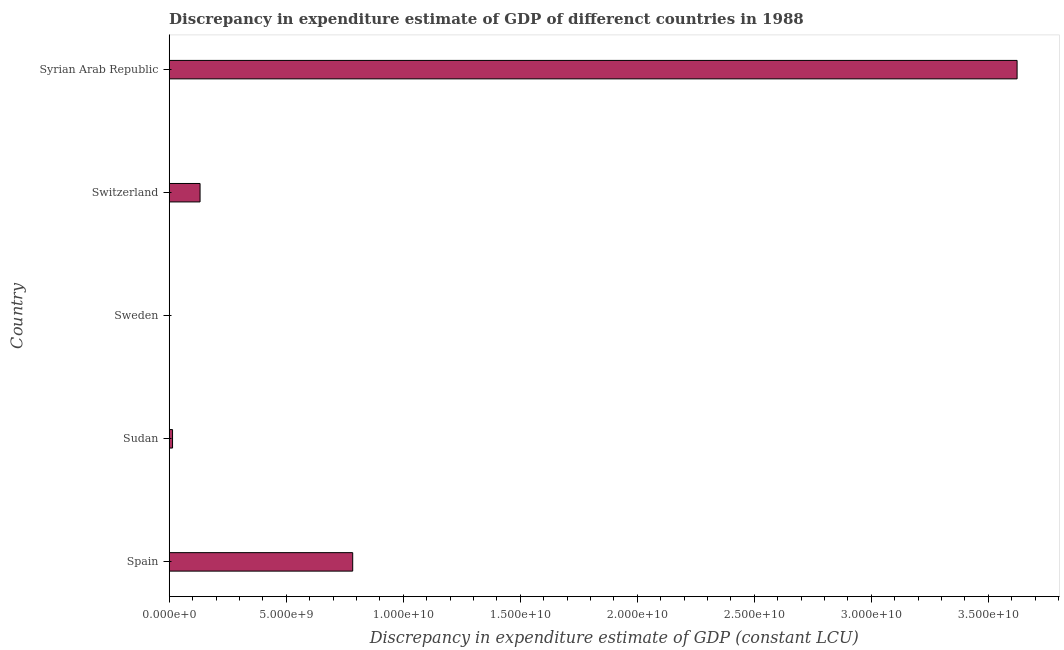Does the graph contain any zero values?
Offer a terse response. Yes. Does the graph contain grids?
Keep it short and to the point. No. What is the title of the graph?
Provide a succinct answer. Discrepancy in expenditure estimate of GDP of differenct countries in 1988. What is the label or title of the X-axis?
Keep it short and to the point. Discrepancy in expenditure estimate of GDP (constant LCU). What is the discrepancy in expenditure estimate of gdp in Switzerland?
Give a very brief answer. 1.32e+09. Across all countries, what is the maximum discrepancy in expenditure estimate of gdp?
Offer a very short reply. 3.62e+1. Across all countries, what is the minimum discrepancy in expenditure estimate of gdp?
Provide a short and direct response. 0. In which country was the discrepancy in expenditure estimate of gdp maximum?
Provide a succinct answer. Syrian Arab Republic. What is the sum of the discrepancy in expenditure estimate of gdp?
Make the answer very short. 4.55e+1. What is the difference between the discrepancy in expenditure estimate of gdp in Spain and Sudan?
Keep it short and to the point. 7.70e+09. What is the average discrepancy in expenditure estimate of gdp per country?
Provide a short and direct response. 9.11e+09. What is the median discrepancy in expenditure estimate of gdp?
Make the answer very short. 1.32e+09. What is the ratio of the discrepancy in expenditure estimate of gdp in Spain to that in Switzerland?
Ensure brevity in your answer.  5.95. Is the discrepancy in expenditure estimate of gdp in Spain less than that in Sudan?
Offer a terse response. No. Is the difference between the discrepancy in expenditure estimate of gdp in Sudan and Switzerland greater than the difference between any two countries?
Offer a very short reply. No. What is the difference between the highest and the second highest discrepancy in expenditure estimate of gdp?
Your answer should be compact. 2.84e+1. Is the sum of the discrepancy in expenditure estimate of gdp in Spain and Switzerland greater than the maximum discrepancy in expenditure estimate of gdp across all countries?
Your answer should be compact. No. What is the difference between the highest and the lowest discrepancy in expenditure estimate of gdp?
Provide a short and direct response. 3.62e+1. In how many countries, is the discrepancy in expenditure estimate of gdp greater than the average discrepancy in expenditure estimate of gdp taken over all countries?
Offer a very short reply. 1. How many countries are there in the graph?
Provide a succinct answer. 5. What is the Discrepancy in expenditure estimate of GDP (constant LCU) in Spain?
Provide a succinct answer. 7.84e+09. What is the Discrepancy in expenditure estimate of GDP (constant LCU) of Sudan?
Give a very brief answer. 1.43e+08. What is the Discrepancy in expenditure estimate of GDP (constant LCU) of Switzerland?
Provide a short and direct response. 1.32e+09. What is the Discrepancy in expenditure estimate of GDP (constant LCU) of Syrian Arab Republic?
Offer a terse response. 3.62e+1. What is the difference between the Discrepancy in expenditure estimate of GDP (constant LCU) in Spain and Sudan?
Keep it short and to the point. 7.70e+09. What is the difference between the Discrepancy in expenditure estimate of GDP (constant LCU) in Spain and Switzerland?
Keep it short and to the point. 6.52e+09. What is the difference between the Discrepancy in expenditure estimate of GDP (constant LCU) in Spain and Syrian Arab Republic?
Your answer should be very brief. -2.84e+1. What is the difference between the Discrepancy in expenditure estimate of GDP (constant LCU) in Sudan and Switzerland?
Offer a terse response. -1.18e+09. What is the difference between the Discrepancy in expenditure estimate of GDP (constant LCU) in Sudan and Syrian Arab Republic?
Ensure brevity in your answer.  -3.61e+1. What is the difference between the Discrepancy in expenditure estimate of GDP (constant LCU) in Switzerland and Syrian Arab Republic?
Provide a succinct answer. -3.49e+1. What is the ratio of the Discrepancy in expenditure estimate of GDP (constant LCU) in Spain to that in Sudan?
Provide a short and direct response. 54.9. What is the ratio of the Discrepancy in expenditure estimate of GDP (constant LCU) in Spain to that in Switzerland?
Your answer should be very brief. 5.95. What is the ratio of the Discrepancy in expenditure estimate of GDP (constant LCU) in Spain to that in Syrian Arab Republic?
Keep it short and to the point. 0.22. What is the ratio of the Discrepancy in expenditure estimate of GDP (constant LCU) in Sudan to that in Switzerland?
Your answer should be compact. 0.11. What is the ratio of the Discrepancy in expenditure estimate of GDP (constant LCU) in Sudan to that in Syrian Arab Republic?
Offer a very short reply. 0. What is the ratio of the Discrepancy in expenditure estimate of GDP (constant LCU) in Switzerland to that in Syrian Arab Republic?
Your answer should be compact. 0.04. 